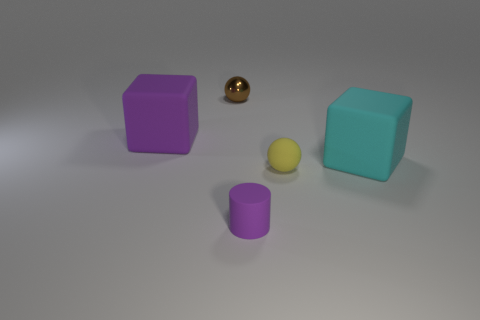There is a large block that is the same color as the rubber cylinder; what material is it?
Keep it short and to the point. Rubber. What is the size of the block that is the same color as the tiny matte cylinder?
Provide a short and direct response. Large. Is there a cube of the same color as the tiny matte cylinder?
Ensure brevity in your answer.  Yes. Are the tiny purple cylinder and the tiny brown thing made of the same material?
Offer a very short reply. No. There is a matte cylinder; is its color the same as the big matte block left of the tiny purple thing?
Provide a succinct answer. Yes. There is a large thing that is the same color as the tiny matte cylinder; what is its shape?
Your answer should be very brief. Cube. What is the color of the tiny shiny object?
Your response must be concise. Brown. What number of objects are rubber cubes or tiny rubber spheres?
Your answer should be very brief. 3. Is there anything else that is the same material as the brown ball?
Ensure brevity in your answer.  No. Is the number of cyan matte cubes in front of the big cyan block less than the number of purple rubber cylinders?
Your answer should be compact. Yes. 